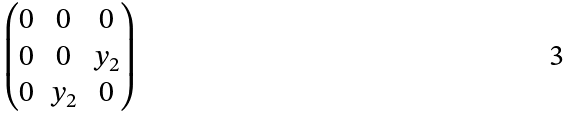<formula> <loc_0><loc_0><loc_500><loc_500>\begin{pmatrix} 0 & 0 & 0 \\ 0 & 0 & y _ { 2 } \\ 0 & y _ { 2 } & 0 \end{pmatrix}</formula> 